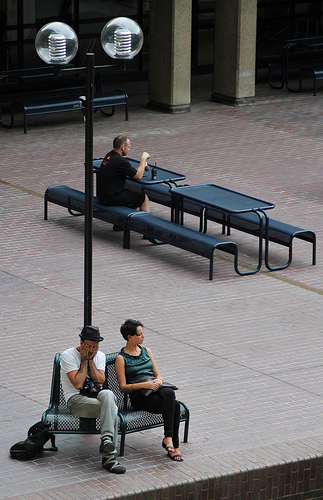Please provide the bounding box coordinate of the region this sentence describes: feet with open toed shoes. The feet adorned with open-toed shoes are captured within the bounding box [0.47, 0.85, 0.53, 0.92], showing a relaxed pose on the bench. 